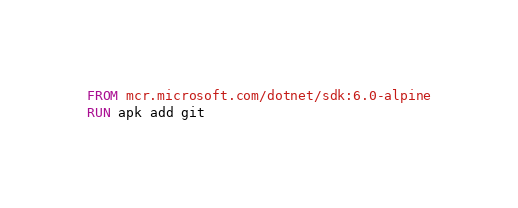<code> <loc_0><loc_0><loc_500><loc_500><_Dockerfile_>FROM mcr.microsoft.com/dotnet/sdk:6.0-alpine
RUN apk add git
</code> 